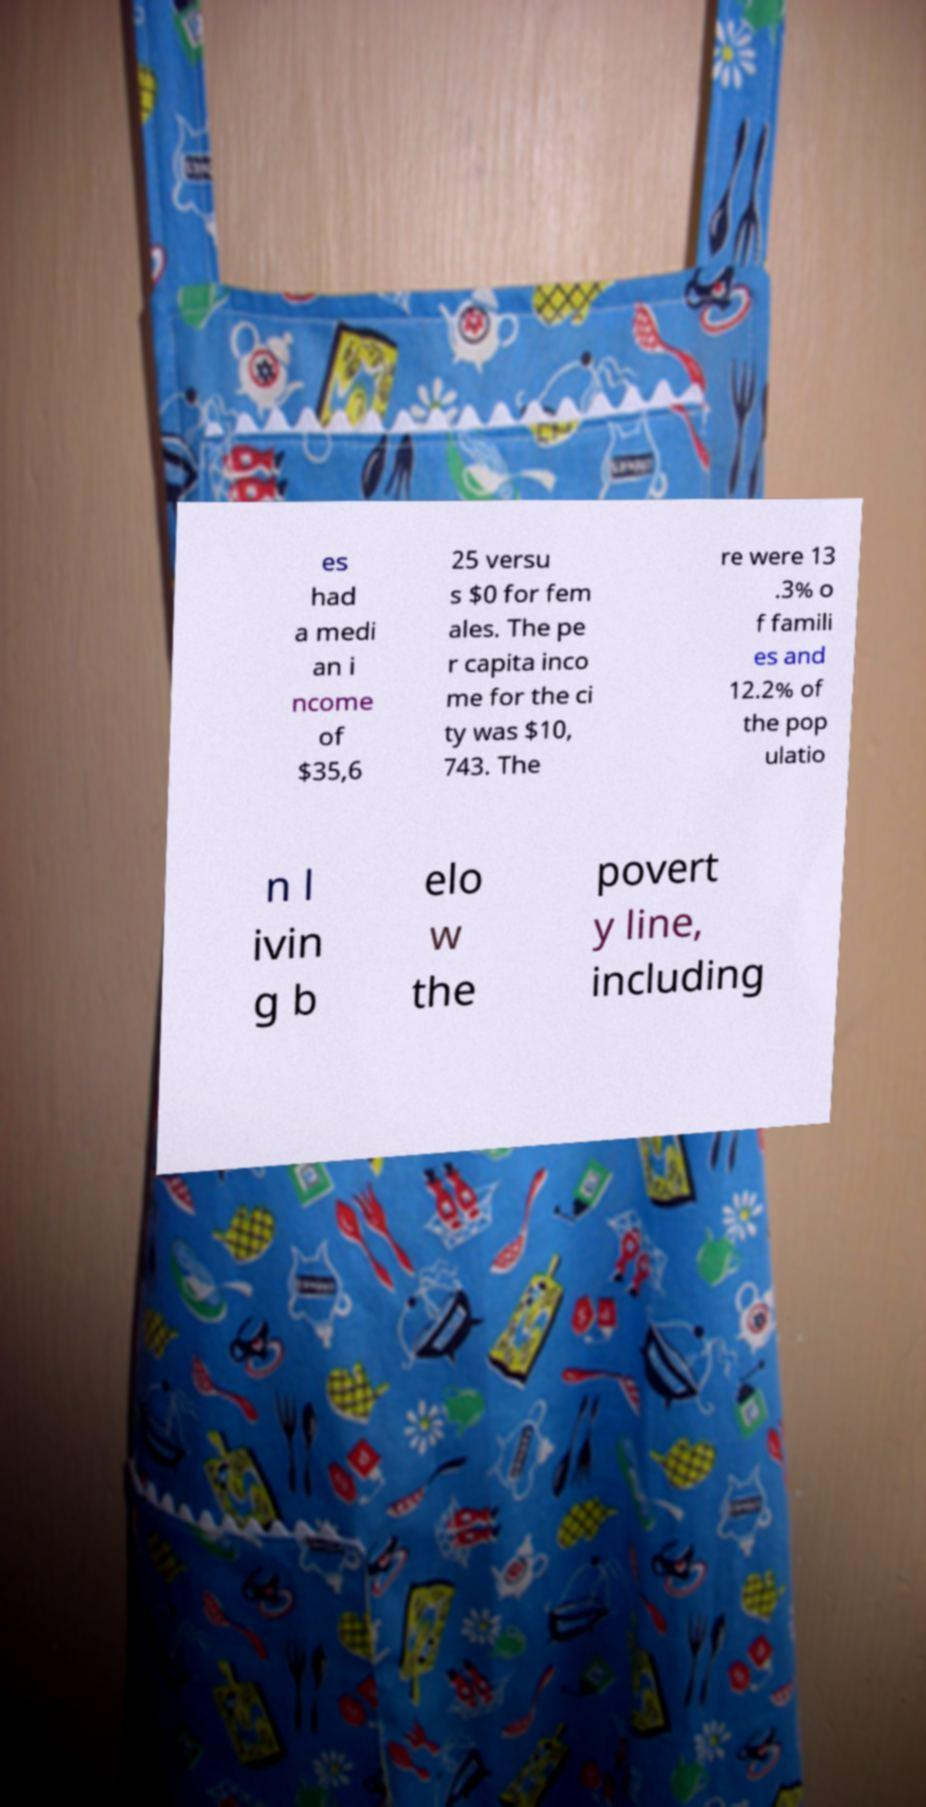Could you assist in decoding the text presented in this image and type it out clearly? es had a medi an i ncome of $35,6 25 versu s $0 for fem ales. The pe r capita inco me for the ci ty was $10, 743. The re were 13 .3% o f famili es and 12.2% of the pop ulatio n l ivin g b elo w the povert y line, including 